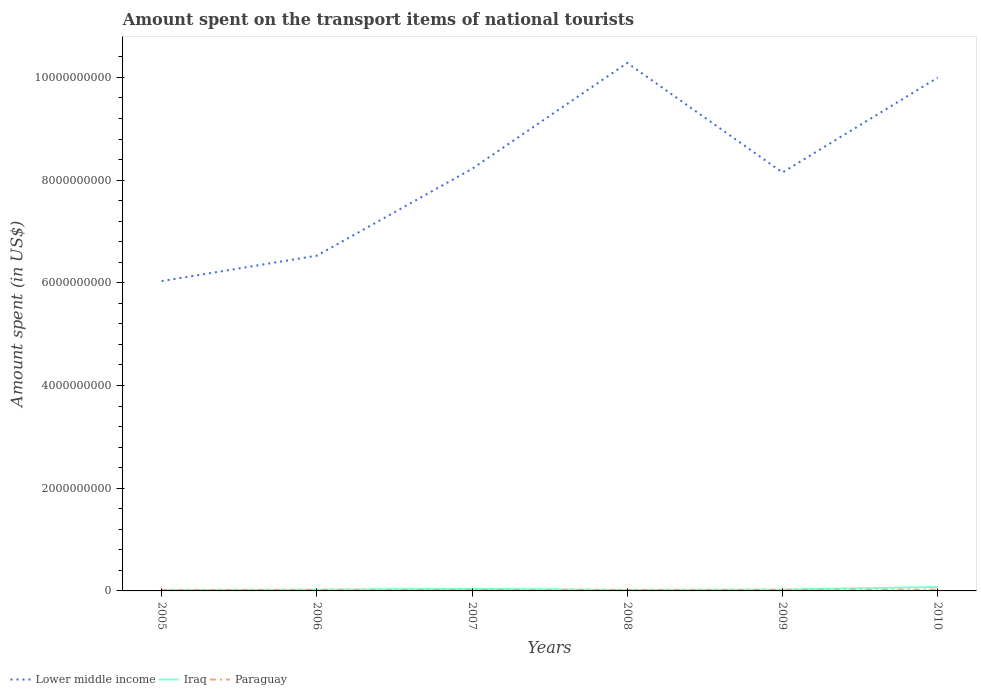Is the number of lines equal to the number of legend labels?
Keep it short and to the point. Yes. Across all years, what is the maximum amount spent on the transport items of national tourists in Iraq?
Ensure brevity in your answer.  1.80e+07. What is the total amount spent on the transport items of national tourists in Paraguay in the graph?
Your answer should be very brief. -8.00e+06. What is the difference between the highest and the second highest amount spent on the transport items of national tourists in Lower middle income?
Provide a succinct answer. 4.25e+09. What is the difference between the highest and the lowest amount spent on the transport items of national tourists in Lower middle income?
Keep it short and to the point. 3. How many lines are there?
Provide a succinct answer. 3. How many years are there in the graph?
Ensure brevity in your answer.  6. What is the difference between two consecutive major ticks on the Y-axis?
Your response must be concise. 2.00e+09. Are the values on the major ticks of Y-axis written in scientific E-notation?
Your response must be concise. No. Where does the legend appear in the graph?
Provide a succinct answer. Bottom left. How are the legend labels stacked?
Give a very brief answer. Horizontal. What is the title of the graph?
Your response must be concise. Amount spent on the transport items of national tourists. What is the label or title of the X-axis?
Give a very brief answer. Years. What is the label or title of the Y-axis?
Your response must be concise. Amount spent (in US$). What is the Amount spent (in US$) in Lower middle income in 2005?
Your response must be concise. 6.03e+09. What is the Amount spent (in US$) in Iraq in 2005?
Your response must be concise. 1.80e+07. What is the Amount spent (in US$) in Paraguay in 2005?
Your answer should be very brief. 1.80e+07. What is the Amount spent (in US$) in Lower middle income in 2006?
Offer a terse response. 6.53e+09. What is the Amount spent (in US$) of Iraq in 2006?
Keep it short and to the point. 2.60e+07. What is the Amount spent (in US$) in Paraguay in 2006?
Offer a terse response. 2.00e+07. What is the Amount spent (in US$) of Lower middle income in 2007?
Ensure brevity in your answer.  8.22e+09. What is the Amount spent (in US$) of Iraq in 2007?
Give a very brief answer. 3.90e+07. What is the Amount spent (in US$) of Paraguay in 2007?
Make the answer very short. 1.90e+07. What is the Amount spent (in US$) of Lower middle income in 2008?
Offer a very short reply. 1.03e+1. What is the Amount spent (in US$) in Iraq in 2008?
Offer a terse response. 2.20e+07. What is the Amount spent (in US$) in Paraguay in 2008?
Offer a terse response. 1.90e+07. What is the Amount spent (in US$) in Lower middle income in 2009?
Keep it short and to the point. 8.15e+09. What is the Amount spent (in US$) in Iraq in 2009?
Provide a short and direct response. 2.70e+07. What is the Amount spent (in US$) of Lower middle income in 2010?
Make the answer very short. 1.00e+1. What is the Amount spent (in US$) of Iraq in 2010?
Provide a succinct answer. 7.60e+07. What is the Amount spent (in US$) of Paraguay in 2010?
Your response must be concise. 2.60e+07. Across all years, what is the maximum Amount spent (in US$) of Lower middle income?
Keep it short and to the point. 1.03e+1. Across all years, what is the maximum Amount spent (in US$) in Iraq?
Provide a short and direct response. 7.60e+07. Across all years, what is the maximum Amount spent (in US$) of Paraguay?
Your response must be concise. 2.60e+07. Across all years, what is the minimum Amount spent (in US$) in Lower middle income?
Your answer should be compact. 6.03e+09. Across all years, what is the minimum Amount spent (in US$) in Iraq?
Give a very brief answer. 1.80e+07. Across all years, what is the minimum Amount spent (in US$) in Paraguay?
Make the answer very short. 1.80e+07. What is the total Amount spent (in US$) of Lower middle income in the graph?
Ensure brevity in your answer.  4.92e+1. What is the total Amount spent (in US$) of Iraq in the graph?
Make the answer very short. 2.08e+08. What is the total Amount spent (in US$) of Paraguay in the graph?
Provide a succinct answer. 1.22e+08. What is the difference between the Amount spent (in US$) of Lower middle income in 2005 and that in 2006?
Make the answer very short. -4.95e+08. What is the difference between the Amount spent (in US$) in Iraq in 2005 and that in 2006?
Provide a succinct answer. -8.00e+06. What is the difference between the Amount spent (in US$) of Paraguay in 2005 and that in 2006?
Keep it short and to the point. -2.00e+06. What is the difference between the Amount spent (in US$) in Lower middle income in 2005 and that in 2007?
Offer a very short reply. -2.19e+09. What is the difference between the Amount spent (in US$) of Iraq in 2005 and that in 2007?
Make the answer very short. -2.10e+07. What is the difference between the Amount spent (in US$) in Lower middle income in 2005 and that in 2008?
Provide a succinct answer. -4.25e+09. What is the difference between the Amount spent (in US$) of Lower middle income in 2005 and that in 2009?
Your response must be concise. -2.12e+09. What is the difference between the Amount spent (in US$) of Iraq in 2005 and that in 2009?
Keep it short and to the point. -9.00e+06. What is the difference between the Amount spent (in US$) of Lower middle income in 2005 and that in 2010?
Offer a terse response. -3.96e+09. What is the difference between the Amount spent (in US$) in Iraq in 2005 and that in 2010?
Give a very brief answer. -5.80e+07. What is the difference between the Amount spent (in US$) of Paraguay in 2005 and that in 2010?
Your answer should be very brief. -8.00e+06. What is the difference between the Amount spent (in US$) in Lower middle income in 2006 and that in 2007?
Keep it short and to the point. -1.69e+09. What is the difference between the Amount spent (in US$) in Iraq in 2006 and that in 2007?
Your answer should be compact. -1.30e+07. What is the difference between the Amount spent (in US$) of Paraguay in 2006 and that in 2007?
Your response must be concise. 1.00e+06. What is the difference between the Amount spent (in US$) in Lower middle income in 2006 and that in 2008?
Make the answer very short. -3.75e+09. What is the difference between the Amount spent (in US$) in Paraguay in 2006 and that in 2008?
Your response must be concise. 1.00e+06. What is the difference between the Amount spent (in US$) of Lower middle income in 2006 and that in 2009?
Your answer should be very brief. -1.62e+09. What is the difference between the Amount spent (in US$) in Lower middle income in 2006 and that in 2010?
Give a very brief answer. -3.47e+09. What is the difference between the Amount spent (in US$) of Iraq in 2006 and that in 2010?
Make the answer very short. -5.00e+07. What is the difference between the Amount spent (in US$) of Paraguay in 2006 and that in 2010?
Provide a short and direct response. -6.00e+06. What is the difference between the Amount spent (in US$) of Lower middle income in 2007 and that in 2008?
Your response must be concise. -2.06e+09. What is the difference between the Amount spent (in US$) of Iraq in 2007 and that in 2008?
Your response must be concise. 1.70e+07. What is the difference between the Amount spent (in US$) in Paraguay in 2007 and that in 2008?
Give a very brief answer. 0. What is the difference between the Amount spent (in US$) of Lower middle income in 2007 and that in 2009?
Provide a succinct answer. 7.14e+07. What is the difference between the Amount spent (in US$) of Iraq in 2007 and that in 2009?
Ensure brevity in your answer.  1.20e+07. What is the difference between the Amount spent (in US$) in Paraguay in 2007 and that in 2009?
Your answer should be compact. -1.00e+06. What is the difference between the Amount spent (in US$) in Lower middle income in 2007 and that in 2010?
Your answer should be very brief. -1.78e+09. What is the difference between the Amount spent (in US$) in Iraq in 2007 and that in 2010?
Make the answer very short. -3.70e+07. What is the difference between the Amount spent (in US$) in Paraguay in 2007 and that in 2010?
Your answer should be compact. -7.00e+06. What is the difference between the Amount spent (in US$) in Lower middle income in 2008 and that in 2009?
Keep it short and to the point. 2.13e+09. What is the difference between the Amount spent (in US$) in Iraq in 2008 and that in 2009?
Your answer should be very brief. -5.00e+06. What is the difference between the Amount spent (in US$) in Paraguay in 2008 and that in 2009?
Your response must be concise. -1.00e+06. What is the difference between the Amount spent (in US$) in Lower middle income in 2008 and that in 2010?
Make the answer very short. 2.86e+08. What is the difference between the Amount spent (in US$) of Iraq in 2008 and that in 2010?
Your response must be concise. -5.40e+07. What is the difference between the Amount spent (in US$) in Paraguay in 2008 and that in 2010?
Your response must be concise. -7.00e+06. What is the difference between the Amount spent (in US$) in Lower middle income in 2009 and that in 2010?
Provide a succinct answer. -1.85e+09. What is the difference between the Amount spent (in US$) of Iraq in 2009 and that in 2010?
Give a very brief answer. -4.90e+07. What is the difference between the Amount spent (in US$) in Paraguay in 2009 and that in 2010?
Offer a very short reply. -6.00e+06. What is the difference between the Amount spent (in US$) in Lower middle income in 2005 and the Amount spent (in US$) in Iraq in 2006?
Keep it short and to the point. 6.01e+09. What is the difference between the Amount spent (in US$) in Lower middle income in 2005 and the Amount spent (in US$) in Paraguay in 2006?
Provide a succinct answer. 6.01e+09. What is the difference between the Amount spent (in US$) in Iraq in 2005 and the Amount spent (in US$) in Paraguay in 2006?
Give a very brief answer. -2.00e+06. What is the difference between the Amount spent (in US$) of Lower middle income in 2005 and the Amount spent (in US$) of Iraq in 2007?
Your response must be concise. 5.99e+09. What is the difference between the Amount spent (in US$) in Lower middle income in 2005 and the Amount spent (in US$) in Paraguay in 2007?
Provide a succinct answer. 6.01e+09. What is the difference between the Amount spent (in US$) in Iraq in 2005 and the Amount spent (in US$) in Paraguay in 2007?
Your answer should be very brief. -1.00e+06. What is the difference between the Amount spent (in US$) of Lower middle income in 2005 and the Amount spent (in US$) of Iraq in 2008?
Your answer should be very brief. 6.01e+09. What is the difference between the Amount spent (in US$) of Lower middle income in 2005 and the Amount spent (in US$) of Paraguay in 2008?
Ensure brevity in your answer.  6.01e+09. What is the difference between the Amount spent (in US$) of Lower middle income in 2005 and the Amount spent (in US$) of Iraq in 2009?
Your response must be concise. 6.01e+09. What is the difference between the Amount spent (in US$) in Lower middle income in 2005 and the Amount spent (in US$) in Paraguay in 2009?
Keep it short and to the point. 6.01e+09. What is the difference between the Amount spent (in US$) in Iraq in 2005 and the Amount spent (in US$) in Paraguay in 2009?
Ensure brevity in your answer.  -2.00e+06. What is the difference between the Amount spent (in US$) in Lower middle income in 2005 and the Amount spent (in US$) in Iraq in 2010?
Your answer should be compact. 5.96e+09. What is the difference between the Amount spent (in US$) in Lower middle income in 2005 and the Amount spent (in US$) in Paraguay in 2010?
Give a very brief answer. 6.01e+09. What is the difference between the Amount spent (in US$) of Iraq in 2005 and the Amount spent (in US$) of Paraguay in 2010?
Your answer should be compact. -8.00e+06. What is the difference between the Amount spent (in US$) of Lower middle income in 2006 and the Amount spent (in US$) of Iraq in 2007?
Make the answer very short. 6.49e+09. What is the difference between the Amount spent (in US$) in Lower middle income in 2006 and the Amount spent (in US$) in Paraguay in 2007?
Make the answer very short. 6.51e+09. What is the difference between the Amount spent (in US$) in Lower middle income in 2006 and the Amount spent (in US$) in Iraq in 2008?
Ensure brevity in your answer.  6.51e+09. What is the difference between the Amount spent (in US$) in Lower middle income in 2006 and the Amount spent (in US$) in Paraguay in 2008?
Your response must be concise. 6.51e+09. What is the difference between the Amount spent (in US$) in Lower middle income in 2006 and the Amount spent (in US$) in Iraq in 2009?
Keep it short and to the point. 6.50e+09. What is the difference between the Amount spent (in US$) of Lower middle income in 2006 and the Amount spent (in US$) of Paraguay in 2009?
Offer a very short reply. 6.51e+09. What is the difference between the Amount spent (in US$) of Lower middle income in 2006 and the Amount spent (in US$) of Iraq in 2010?
Provide a short and direct response. 6.45e+09. What is the difference between the Amount spent (in US$) in Lower middle income in 2006 and the Amount spent (in US$) in Paraguay in 2010?
Make the answer very short. 6.50e+09. What is the difference between the Amount spent (in US$) in Iraq in 2006 and the Amount spent (in US$) in Paraguay in 2010?
Offer a terse response. 0. What is the difference between the Amount spent (in US$) in Lower middle income in 2007 and the Amount spent (in US$) in Iraq in 2008?
Offer a very short reply. 8.20e+09. What is the difference between the Amount spent (in US$) in Lower middle income in 2007 and the Amount spent (in US$) in Paraguay in 2008?
Provide a succinct answer. 8.20e+09. What is the difference between the Amount spent (in US$) of Iraq in 2007 and the Amount spent (in US$) of Paraguay in 2008?
Give a very brief answer. 2.00e+07. What is the difference between the Amount spent (in US$) in Lower middle income in 2007 and the Amount spent (in US$) in Iraq in 2009?
Offer a very short reply. 8.19e+09. What is the difference between the Amount spent (in US$) of Lower middle income in 2007 and the Amount spent (in US$) of Paraguay in 2009?
Your response must be concise. 8.20e+09. What is the difference between the Amount spent (in US$) of Iraq in 2007 and the Amount spent (in US$) of Paraguay in 2009?
Your response must be concise. 1.90e+07. What is the difference between the Amount spent (in US$) of Lower middle income in 2007 and the Amount spent (in US$) of Iraq in 2010?
Your answer should be very brief. 8.14e+09. What is the difference between the Amount spent (in US$) of Lower middle income in 2007 and the Amount spent (in US$) of Paraguay in 2010?
Ensure brevity in your answer.  8.19e+09. What is the difference between the Amount spent (in US$) in Iraq in 2007 and the Amount spent (in US$) in Paraguay in 2010?
Offer a very short reply. 1.30e+07. What is the difference between the Amount spent (in US$) of Lower middle income in 2008 and the Amount spent (in US$) of Iraq in 2009?
Provide a short and direct response. 1.03e+1. What is the difference between the Amount spent (in US$) of Lower middle income in 2008 and the Amount spent (in US$) of Paraguay in 2009?
Provide a short and direct response. 1.03e+1. What is the difference between the Amount spent (in US$) of Iraq in 2008 and the Amount spent (in US$) of Paraguay in 2009?
Your answer should be very brief. 2.00e+06. What is the difference between the Amount spent (in US$) of Lower middle income in 2008 and the Amount spent (in US$) of Iraq in 2010?
Make the answer very short. 1.02e+1. What is the difference between the Amount spent (in US$) of Lower middle income in 2008 and the Amount spent (in US$) of Paraguay in 2010?
Offer a terse response. 1.03e+1. What is the difference between the Amount spent (in US$) in Iraq in 2008 and the Amount spent (in US$) in Paraguay in 2010?
Offer a terse response. -4.00e+06. What is the difference between the Amount spent (in US$) of Lower middle income in 2009 and the Amount spent (in US$) of Iraq in 2010?
Your response must be concise. 8.07e+09. What is the difference between the Amount spent (in US$) of Lower middle income in 2009 and the Amount spent (in US$) of Paraguay in 2010?
Your answer should be compact. 8.12e+09. What is the difference between the Amount spent (in US$) of Iraq in 2009 and the Amount spent (in US$) of Paraguay in 2010?
Your response must be concise. 1.00e+06. What is the average Amount spent (in US$) in Lower middle income per year?
Offer a very short reply. 8.20e+09. What is the average Amount spent (in US$) of Iraq per year?
Make the answer very short. 3.47e+07. What is the average Amount spent (in US$) in Paraguay per year?
Provide a short and direct response. 2.03e+07. In the year 2005, what is the difference between the Amount spent (in US$) of Lower middle income and Amount spent (in US$) of Iraq?
Offer a terse response. 6.02e+09. In the year 2005, what is the difference between the Amount spent (in US$) in Lower middle income and Amount spent (in US$) in Paraguay?
Offer a very short reply. 6.02e+09. In the year 2006, what is the difference between the Amount spent (in US$) of Lower middle income and Amount spent (in US$) of Iraq?
Ensure brevity in your answer.  6.50e+09. In the year 2006, what is the difference between the Amount spent (in US$) of Lower middle income and Amount spent (in US$) of Paraguay?
Offer a terse response. 6.51e+09. In the year 2006, what is the difference between the Amount spent (in US$) in Iraq and Amount spent (in US$) in Paraguay?
Offer a very short reply. 6.00e+06. In the year 2007, what is the difference between the Amount spent (in US$) in Lower middle income and Amount spent (in US$) in Iraq?
Offer a very short reply. 8.18e+09. In the year 2007, what is the difference between the Amount spent (in US$) of Lower middle income and Amount spent (in US$) of Paraguay?
Ensure brevity in your answer.  8.20e+09. In the year 2007, what is the difference between the Amount spent (in US$) in Iraq and Amount spent (in US$) in Paraguay?
Provide a succinct answer. 2.00e+07. In the year 2008, what is the difference between the Amount spent (in US$) in Lower middle income and Amount spent (in US$) in Iraq?
Provide a succinct answer. 1.03e+1. In the year 2008, what is the difference between the Amount spent (in US$) of Lower middle income and Amount spent (in US$) of Paraguay?
Your response must be concise. 1.03e+1. In the year 2008, what is the difference between the Amount spent (in US$) in Iraq and Amount spent (in US$) in Paraguay?
Make the answer very short. 3.00e+06. In the year 2009, what is the difference between the Amount spent (in US$) of Lower middle income and Amount spent (in US$) of Iraq?
Provide a short and direct response. 8.12e+09. In the year 2009, what is the difference between the Amount spent (in US$) in Lower middle income and Amount spent (in US$) in Paraguay?
Ensure brevity in your answer.  8.13e+09. In the year 2010, what is the difference between the Amount spent (in US$) of Lower middle income and Amount spent (in US$) of Iraq?
Give a very brief answer. 9.92e+09. In the year 2010, what is the difference between the Amount spent (in US$) of Lower middle income and Amount spent (in US$) of Paraguay?
Provide a short and direct response. 9.97e+09. In the year 2010, what is the difference between the Amount spent (in US$) in Iraq and Amount spent (in US$) in Paraguay?
Your response must be concise. 5.00e+07. What is the ratio of the Amount spent (in US$) of Lower middle income in 2005 to that in 2006?
Offer a very short reply. 0.92. What is the ratio of the Amount spent (in US$) of Iraq in 2005 to that in 2006?
Provide a short and direct response. 0.69. What is the ratio of the Amount spent (in US$) of Paraguay in 2005 to that in 2006?
Your answer should be compact. 0.9. What is the ratio of the Amount spent (in US$) of Lower middle income in 2005 to that in 2007?
Ensure brevity in your answer.  0.73. What is the ratio of the Amount spent (in US$) of Iraq in 2005 to that in 2007?
Make the answer very short. 0.46. What is the ratio of the Amount spent (in US$) of Lower middle income in 2005 to that in 2008?
Provide a short and direct response. 0.59. What is the ratio of the Amount spent (in US$) of Iraq in 2005 to that in 2008?
Provide a succinct answer. 0.82. What is the ratio of the Amount spent (in US$) in Lower middle income in 2005 to that in 2009?
Keep it short and to the point. 0.74. What is the ratio of the Amount spent (in US$) of Iraq in 2005 to that in 2009?
Offer a terse response. 0.67. What is the ratio of the Amount spent (in US$) in Paraguay in 2005 to that in 2009?
Offer a terse response. 0.9. What is the ratio of the Amount spent (in US$) of Lower middle income in 2005 to that in 2010?
Make the answer very short. 0.6. What is the ratio of the Amount spent (in US$) in Iraq in 2005 to that in 2010?
Provide a succinct answer. 0.24. What is the ratio of the Amount spent (in US$) of Paraguay in 2005 to that in 2010?
Offer a very short reply. 0.69. What is the ratio of the Amount spent (in US$) of Lower middle income in 2006 to that in 2007?
Offer a terse response. 0.79. What is the ratio of the Amount spent (in US$) in Paraguay in 2006 to that in 2007?
Ensure brevity in your answer.  1.05. What is the ratio of the Amount spent (in US$) in Lower middle income in 2006 to that in 2008?
Give a very brief answer. 0.64. What is the ratio of the Amount spent (in US$) of Iraq in 2006 to that in 2008?
Make the answer very short. 1.18. What is the ratio of the Amount spent (in US$) of Paraguay in 2006 to that in 2008?
Your answer should be very brief. 1.05. What is the ratio of the Amount spent (in US$) of Lower middle income in 2006 to that in 2009?
Ensure brevity in your answer.  0.8. What is the ratio of the Amount spent (in US$) of Iraq in 2006 to that in 2009?
Provide a succinct answer. 0.96. What is the ratio of the Amount spent (in US$) in Paraguay in 2006 to that in 2009?
Offer a terse response. 1. What is the ratio of the Amount spent (in US$) of Lower middle income in 2006 to that in 2010?
Your response must be concise. 0.65. What is the ratio of the Amount spent (in US$) of Iraq in 2006 to that in 2010?
Give a very brief answer. 0.34. What is the ratio of the Amount spent (in US$) in Paraguay in 2006 to that in 2010?
Your response must be concise. 0.77. What is the ratio of the Amount spent (in US$) of Lower middle income in 2007 to that in 2008?
Provide a succinct answer. 0.8. What is the ratio of the Amount spent (in US$) of Iraq in 2007 to that in 2008?
Give a very brief answer. 1.77. What is the ratio of the Amount spent (in US$) of Paraguay in 2007 to that in 2008?
Your answer should be very brief. 1. What is the ratio of the Amount spent (in US$) of Lower middle income in 2007 to that in 2009?
Your answer should be compact. 1.01. What is the ratio of the Amount spent (in US$) of Iraq in 2007 to that in 2009?
Give a very brief answer. 1.44. What is the ratio of the Amount spent (in US$) in Lower middle income in 2007 to that in 2010?
Your answer should be compact. 0.82. What is the ratio of the Amount spent (in US$) of Iraq in 2007 to that in 2010?
Provide a short and direct response. 0.51. What is the ratio of the Amount spent (in US$) of Paraguay in 2007 to that in 2010?
Your answer should be very brief. 0.73. What is the ratio of the Amount spent (in US$) in Lower middle income in 2008 to that in 2009?
Make the answer very short. 1.26. What is the ratio of the Amount spent (in US$) of Iraq in 2008 to that in 2009?
Offer a very short reply. 0.81. What is the ratio of the Amount spent (in US$) in Lower middle income in 2008 to that in 2010?
Give a very brief answer. 1.03. What is the ratio of the Amount spent (in US$) of Iraq in 2008 to that in 2010?
Ensure brevity in your answer.  0.29. What is the ratio of the Amount spent (in US$) in Paraguay in 2008 to that in 2010?
Make the answer very short. 0.73. What is the ratio of the Amount spent (in US$) of Lower middle income in 2009 to that in 2010?
Your answer should be compact. 0.82. What is the ratio of the Amount spent (in US$) of Iraq in 2009 to that in 2010?
Provide a succinct answer. 0.36. What is the ratio of the Amount spent (in US$) in Paraguay in 2009 to that in 2010?
Offer a terse response. 0.77. What is the difference between the highest and the second highest Amount spent (in US$) of Lower middle income?
Provide a succinct answer. 2.86e+08. What is the difference between the highest and the second highest Amount spent (in US$) in Iraq?
Your answer should be compact. 3.70e+07. What is the difference between the highest and the lowest Amount spent (in US$) of Lower middle income?
Offer a terse response. 4.25e+09. What is the difference between the highest and the lowest Amount spent (in US$) in Iraq?
Make the answer very short. 5.80e+07. What is the difference between the highest and the lowest Amount spent (in US$) in Paraguay?
Your answer should be compact. 8.00e+06. 